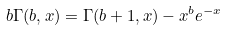<formula> <loc_0><loc_0><loc_500><loc_500>b \Gamma ( b , x ) = \Gamma ( b + 1 , x ) - x ^ { b } e ^ { - x }</formula> 